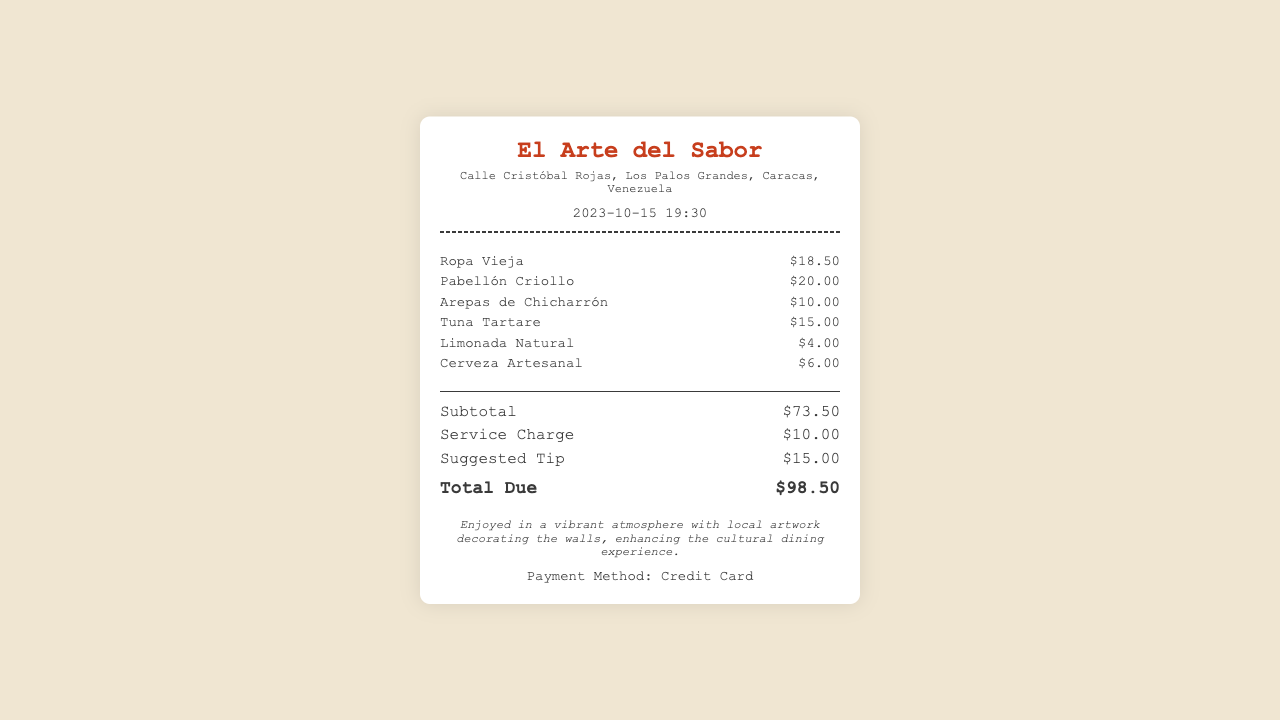What is the name of the restaurant? The name of the restaurant is located at the top of the receipt.
Answer: El Arte del Sabor What is the address of the restaurant? The address is listed under the restaurant name in the receipt.
Answer: Calle Cristóbal Rojas, Los Palos Grandes, Caracas, Venezuela What was the date and time of the visit? The date and time are mentioned in the header section of the receipt.
Answer: 2023-10-15 19:30 How much was the suggested tip? The suggested tip is found in the totals section of the receipt.
Answer: $15.00 What is the cost of Ropa Vieja? The price of Ropa Vieja can be found in the items section of the receipt.
Answer: $18.50 What is the total due amount? The total due amount is calculated in the totals section of the receipt.
Answer: $98.50 How many food items were ordered? The number of food items can be counted from the items listed in the receipt.
Answer: 5 What payment method was used? The payment method is indicated at the bottom of the receipt.
Answer: Credit Card What kind of atmosphere was described in the experience section? The atmosphere is described in the experience section which highlights the decor.
Answer: vibrant atmosphere with local artwork 